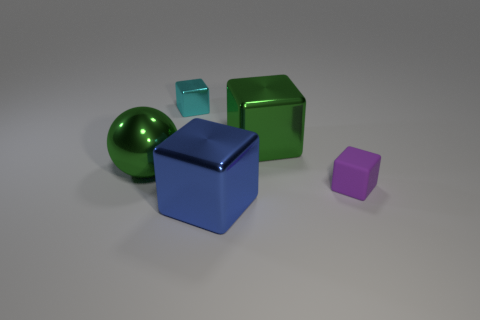Add 3 cyan blocks. How many objects exist? 8 Subtract all tiny cyan cubes. How many cubes are left? 3 Subtract all green blocks. How many blocks are left? 3 Subtract all balls. How many objects are left? 4 Subtract 1 cubes. How many cubes are left? 3 Add 4 green metallic cubes. How many green metallic cubes exist? 5 Subtract 0 gray spheres. How many objects are left? 5 Subtract all yellow cubes. Subtract all cyan spheres. How many cubes are left? 4 Subtract all yellow cylinders. How many cyan cubes are left? 1 Subtract all big objects. Subtract all large metallic cubes. How many objects are left? 0 